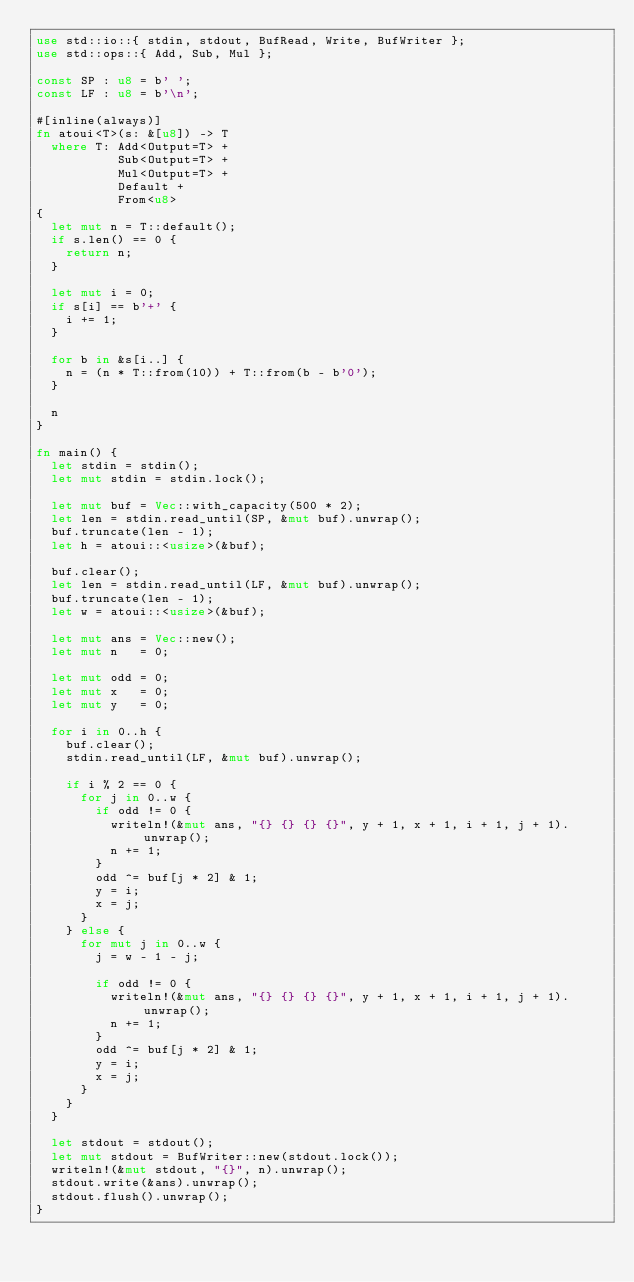<code> <loc_0><loc_0><loc_500><loc_500><_Rust_>use std::io::{ stdin, stdout, BufRead, Write, BufWriter };
use std::ops::{ Add, Sub, Mul };

const SP : u8 = b' ';
const LF : u8 = b'\n';

#[inline(always)]
fn atoui<T>(s: &[u8]) -> T
  where T: Add<Output=T> +
           Sub<Output=T> +
           Mul<Output=T> +
           Default +
           From<u8>
{
  let mut n = T::default();
  if s.len() == 0 {
    return n;
  }

  let mut i = 0;
  if s[i] == b'+' {
    i += 1;
  }

  for b in &s[i..] {
    n = (n * T::from(10)) + T::from(b - b'0');
  }

  n
}

fn main() {
  let stdin = stdin();
  let mut stdin = stdin.lock();

  let mut buf = Vec::with_capacity(500 * 2);
  let len = stdin.read_until(SP, &mut buf).unwrap();
  buf.truncate(len - 1);
  let h = atoui::<usize>(&buf);

  buf.clear();
  let len = stdin.read_until(LF, &mut buf).unwrap();
  buf.truncate(len - 1);
  let w = atoui::<usize>(&buf);

  let mut ans = Vec::new();
  let mut n   = 0;

  let mut odd = 0;
  let mut x   = 0;
  let mut y   = 0;

  for i in 0..h {
    buf.clear();
    stdin.read_until(LF, &mut buf).unwrap();

    if i % 2 == 0 {
      for j in 0..w {
        if odd != 0 {
          writeln!(&mut ans, "{} {} {} {}", y + 1, x + 1, i + 1, j + 1).unwrap();
          n += 1;
        }
        odd ^= buf[j * 2] & 1;
        y = i;
        x = j;
      }
    } else {
      for mut j in 0..w {
        j = w - 1 - j;

        if odd != 0 {
          writeln!(&mut ans, "{} {} {} {}", y + 1, x + 1, i + 1, j + 1).unwrap();
          n += 1;
        }
        odd ^= buf[j * 2] & 1;
        y = i;
        x = j;
      }
    }
  }

  let stdout = stdout();
  let mut stdout = BufWriter::new(stdout.lock());
  writeln!(&mut stdout, "{}", n).unwrap();
  stdout.write(&ans).unwrap();
  stdout.flush().unwrap();
}
</code> 